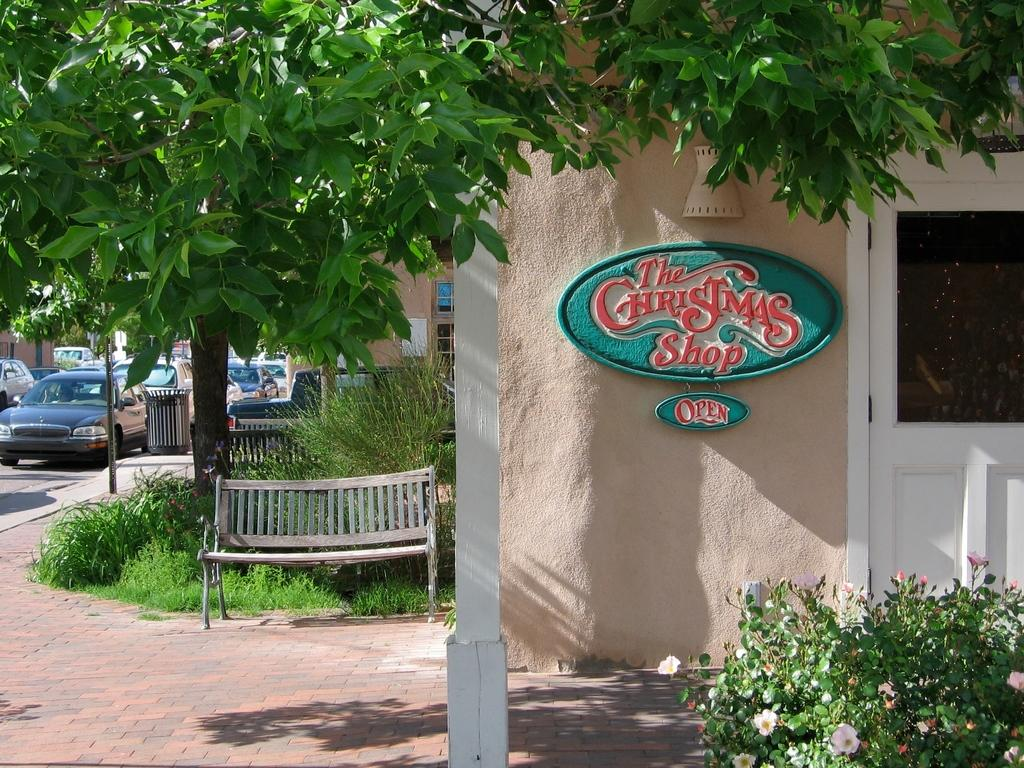What type of seating is visible in the image? There is a bench in the image. What type of vegetation is present in the image? There is grass in the image. What type of structure is visible in the image? There is a wall in the image. What type of entrance is present in the image? There is a door in the image. What type of transportation can be seen on the road in the image? There are vehicles on the road in the image. What type of vertical structure is present in the image? There is a pole in the image. What type of decorative plants are present in the image? There are flowers in the image. What type of bells can be heard ringing in the image? There are no bells present in the image, and therefore no sound can be heard. How many cars are parked in the image? The provided facts do not mention any cars in the image, only vehicles in general. 